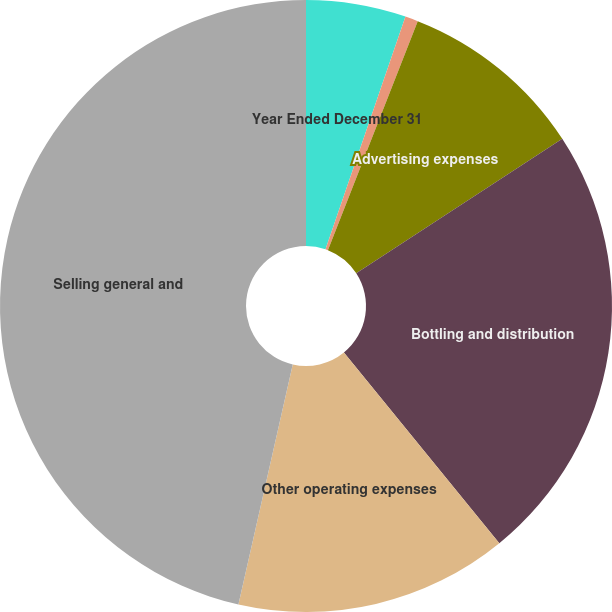Convert chart. <chart><loc_0><loc_0><loc_500><loc_500><pie_chart><fcel>Year Ended December 31<fcel>Stock-based compensation<fcel>Advertising expenses<fcel>Bottling and distribution<fcel>Other operating expenses<fcel>Selling general and<nl><fcel>5.27%<fcel>0.68%<fcel>9.85%<fcel>23.32%<fcel>14.43%<fcel>46.46%<nl></chart> 